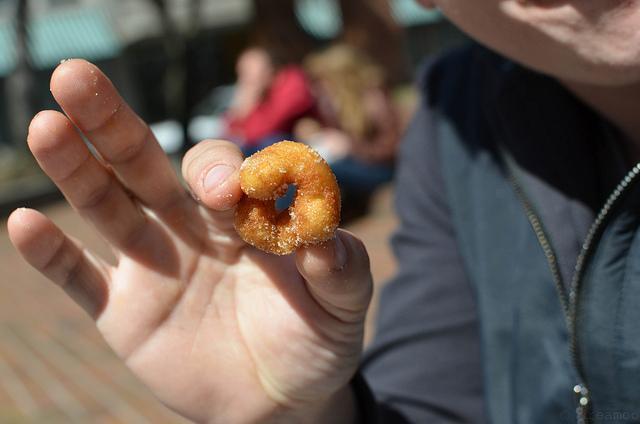How many fingers are pointing upward?
Give a very brief answer. 3. How many people are in the photo?
Give a very brief answer. 2. 